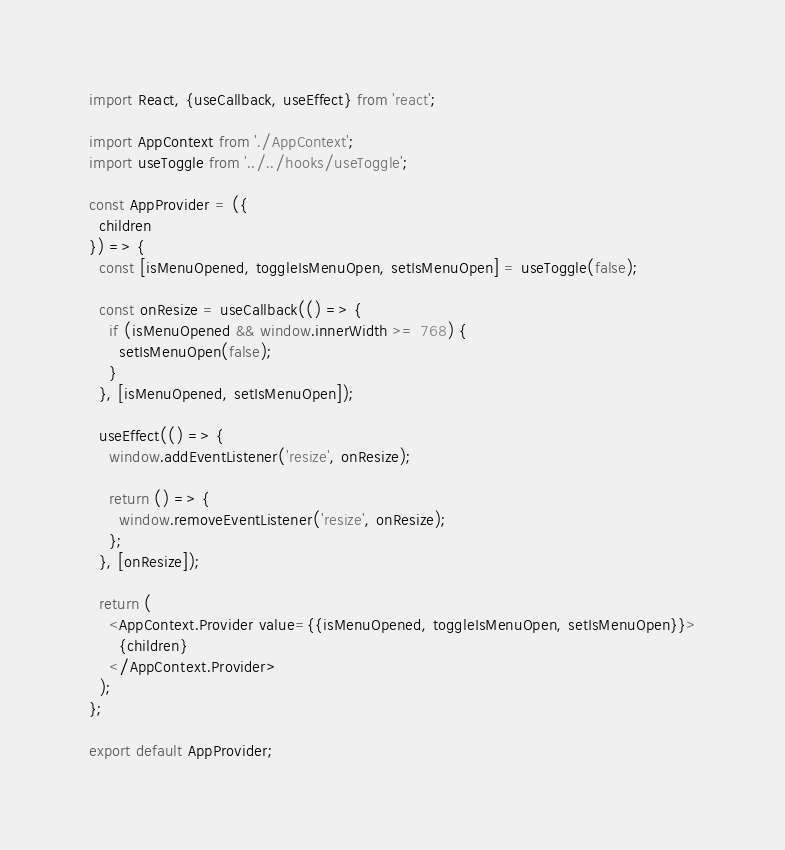<code> <loc_0><loc_0><loc_500><loc_500><_JavaScript_>import React, {useCallback, useEffect} from 'react';

import AppContext from './AppContext';
import useToggle from '../../hooks/useToggle';

const AppProvider = ({
  children
}) => {
  const [isMenuOpened, toggleIsMenuOpen, setIsMenuOpen] = useToggle(false);

  const onResize = useCallback(() => {
    if (isMenuOpened && window.innerWidth >= 768) {
      setIsMenuOpen(false);
    }
  }, [isMenuOpened, setIsMenuOpen]);

  useEffect(() => {
    window.addEventListener('resize', onResize);

    return () => {
      window.removeEventListener('resize', onResize);
    };
  }, [onResize]);

  return (
    <AppContext.Provider value={{isMenuOpened, toggleIsMenuOpen, setIsMenuOpen}}>
      {children}
    </AppContext.Provider>
  );
};

export default AppProvider;
</code> 